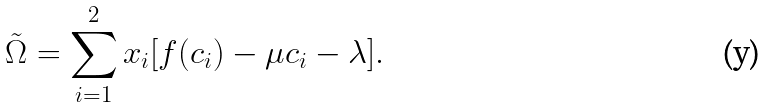<formula> <loc_0><loc_0><loc_500><loc_500>\tilde { \Omega } = \sum _ { i = 1 } ^ { 2 } x _ { i } [ f ( c _ { i } ) - \mu c _ { i } - \lambda ] .</formula> 